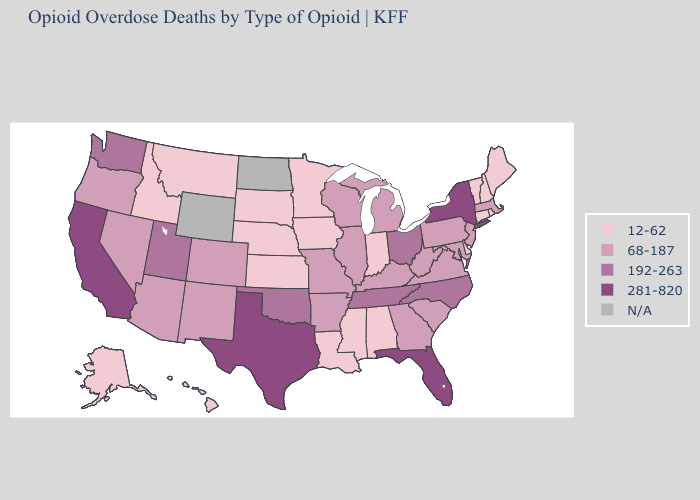Does Alaska have the highest value in the USA?
Short answer required. No. Among the states that border Louisiana , which have the highest value?
Quick response, please. Texas. Which states have the lowest value in the USA?
Be succinct. Alabama, Alaska, Connecticut, Delaware, Hawaii, Idaho, Indiana, Iowa, Kansas, Louisiana, Maine, Minnesota, Mississippi, Montana, Nebraska, New Hampshire, Rhode Island, South Dakota, Vermont. What is the highest value in the USA?
Answer briefly. 281-820. Does New Jersey have the lowest value in the USA?
Keep it brief. No. What is the lowest value in the USA?
Short answer required. 12-62. Name the states that have a value in the range N/A?
Write a very short answer. North Dakota, Wyoming. Name the states that have a value in the range 281-820?
Give a very brief answer. California, Florida, New York, Texas. Does the first symbol in the legend represent the smallest category?
Give a very brief answer. Yes. Which states have the lowest value in the USA?
Write a very short answer. Alabama, Alaska, Connecticut, Delaware, Hawaii, Idaho, Indiana, Iowa, Kansas, Louisiana, Maine, Minnesota, Mississippi, Montana, Nebraska, New Hampshire, Rhode Island, South Dakota, Vermont. Name the states that have a value in the range 192-263?
Concise answer only. North Carolina, Ohio, Oklahoma, Tennessee, Utah, Washington. Among the states that border Mississippi , does Louisiana have the lowest value?
Quick response, please. Yes. Among the states that border Louisiana , does Arkansas have the highest value?
Give a very brief answer. No. 